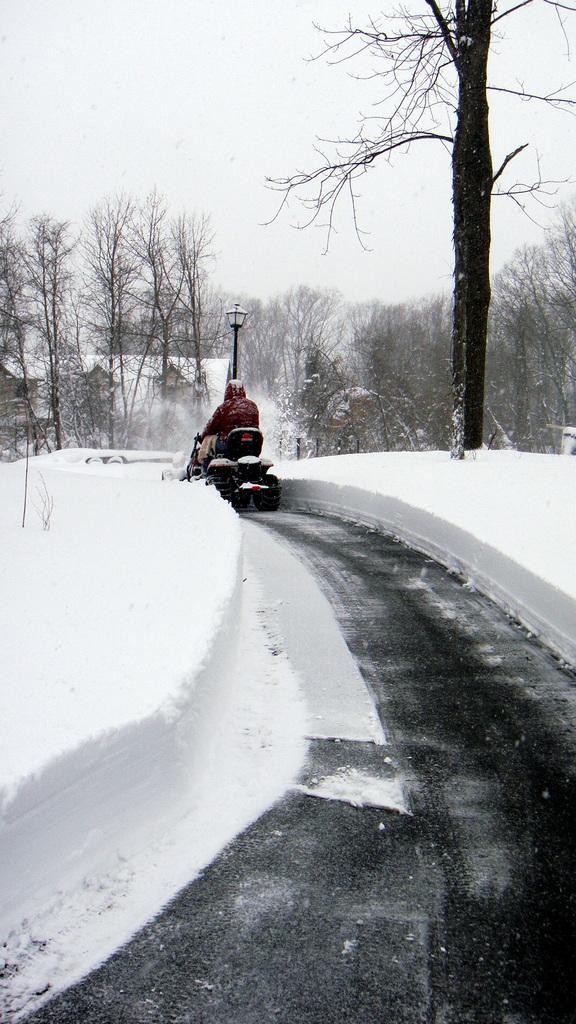In one or two sentences, can you explain what this image depicts? In this picture I can see a person riding vehicle on the road, side I can see full of snow and some trees covered with snow. 